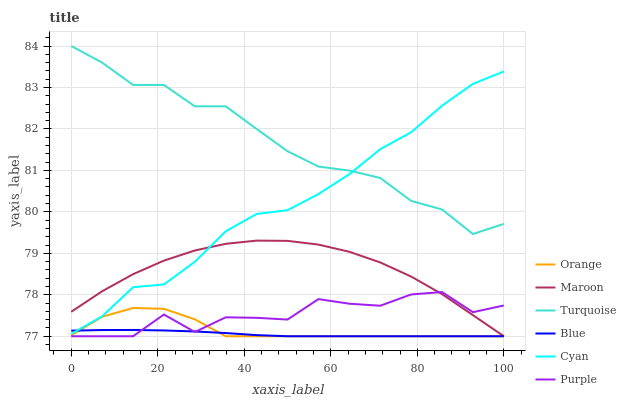Does Blue have the minimum area under the curve?
Answer yes or no. Yes. Does Turquoise have the maximum area under the curve?
Answer yes or no. Yes. Does Purple have the minimum area under the curve?
Answer yes or no. No. Does Purple have the maximum area under the curve?
Answer yes or no. No. Is Blue the smoothest?
Answer yes or no. Yes. Is Purple the roughest?
Answer yes or no. Yes. Is Turquoise the smoothest?
Answer yes or no. No. Is Turquoise the roughest?
Answer yes or no. No. Does Blue have the lowest value?
Answer yes or no. Yes. Does Turquoise have the lowest value?
Answer yes or no. No. Does Turquoise have the highest value?
Answer yes or no. Yes. Does Purple have the highest value?
Answer yes or no. No. Is Orange less than Turquoise?
Answer yes or no. Yes. Is Turquoise greater than Blue?
Answer yes or no. Yes. Does Orange intersect Maroon?
Answer yes or no. Yes. Is Orange less than Maroon?
Answer yes or no. No. Is Orange greater than Maroon?
Answer yes or no. No. Does Orange intersect Turquoise?
Answer yes or no. No. 